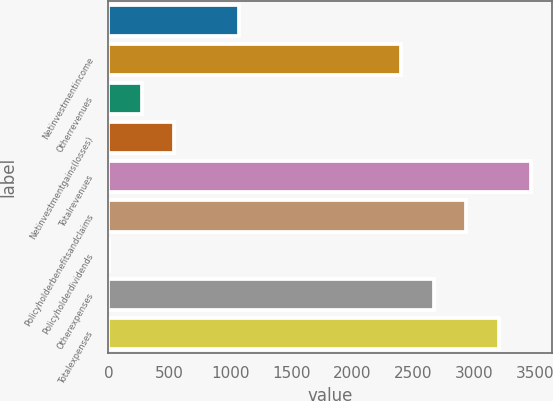Convert chart to OTSL. <chart><loc_0><loc_0><loc_500><loc_500><bar_chart><ecel><fcel>Netinvestmentincome<fcel>Otherrevenues<fcel>Netinvestmentgains(losses)<fcel>Totalrevenues<fcel>Policyholderbenefitsandclaims<fcel>Policyholderdividends<fcel>Otherexpenses<fcel>Totalexpenses<nl><fcel>1071.6<fcel>2403.6<fcel>272.4<fcel>538.8<fcel>3469.2<fcel>2936.4<fcel>6<fcel>2670<fcel>3202.8<nl></chart> 